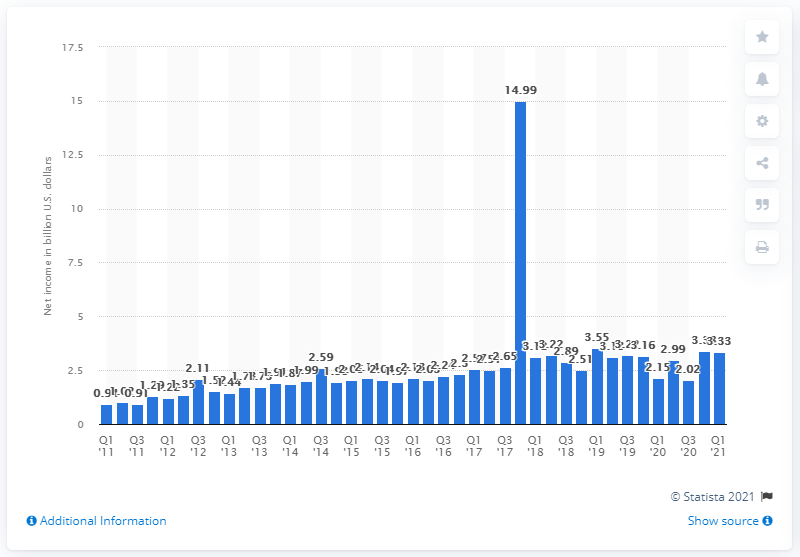Mention a couple of crucial points in this snapshot. Comcast's net income in the first quarter of 2021 was 3.33 billion dollars. Comcast's net income in the fourth quarter of 2020 was $3.38 billion. 